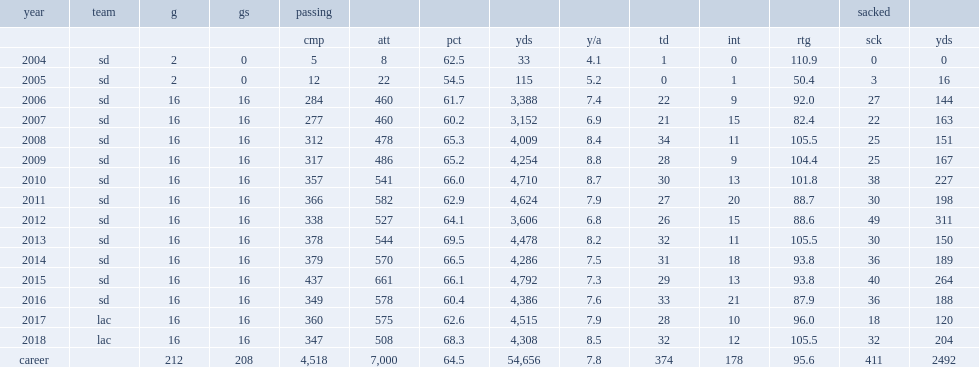How many sacked yards did philip rivers have in 2010? 227.0. 